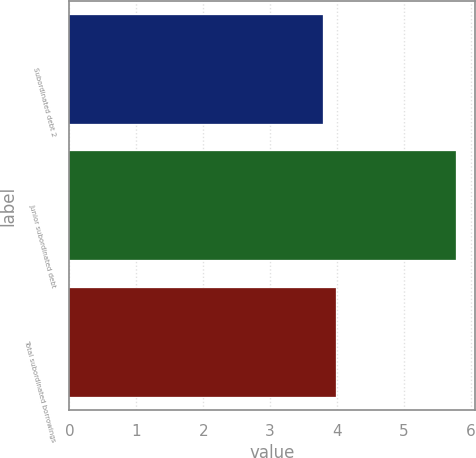Convert chart to OTSL. <chart><loc_0><loc_0><loc_500><loc_500><bar_chart><fcel>Subordinated debt 2<fcel>Junior subordinated debt<fcel>Total subordinated borrowings<nl><fcel>3.79<fcel>5.77<fcel>3.99<nl></chart> 